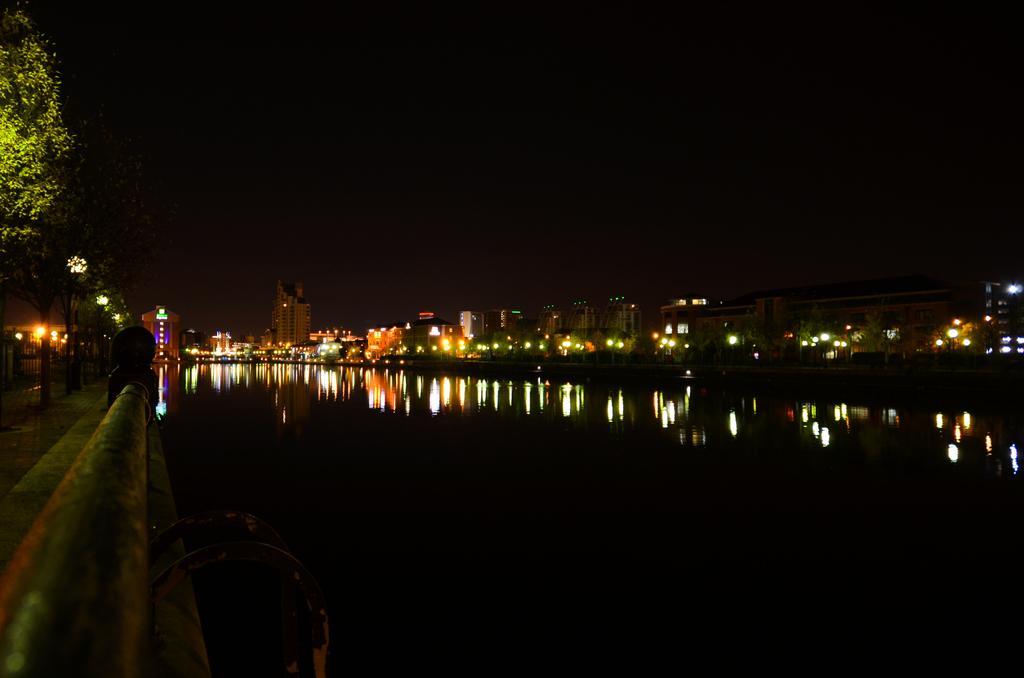How would you summarize this image in a sentence or two? In the picture I can see a fence and few trees in the left corner and there is water beside it and there are few buildings and lights in the background. 